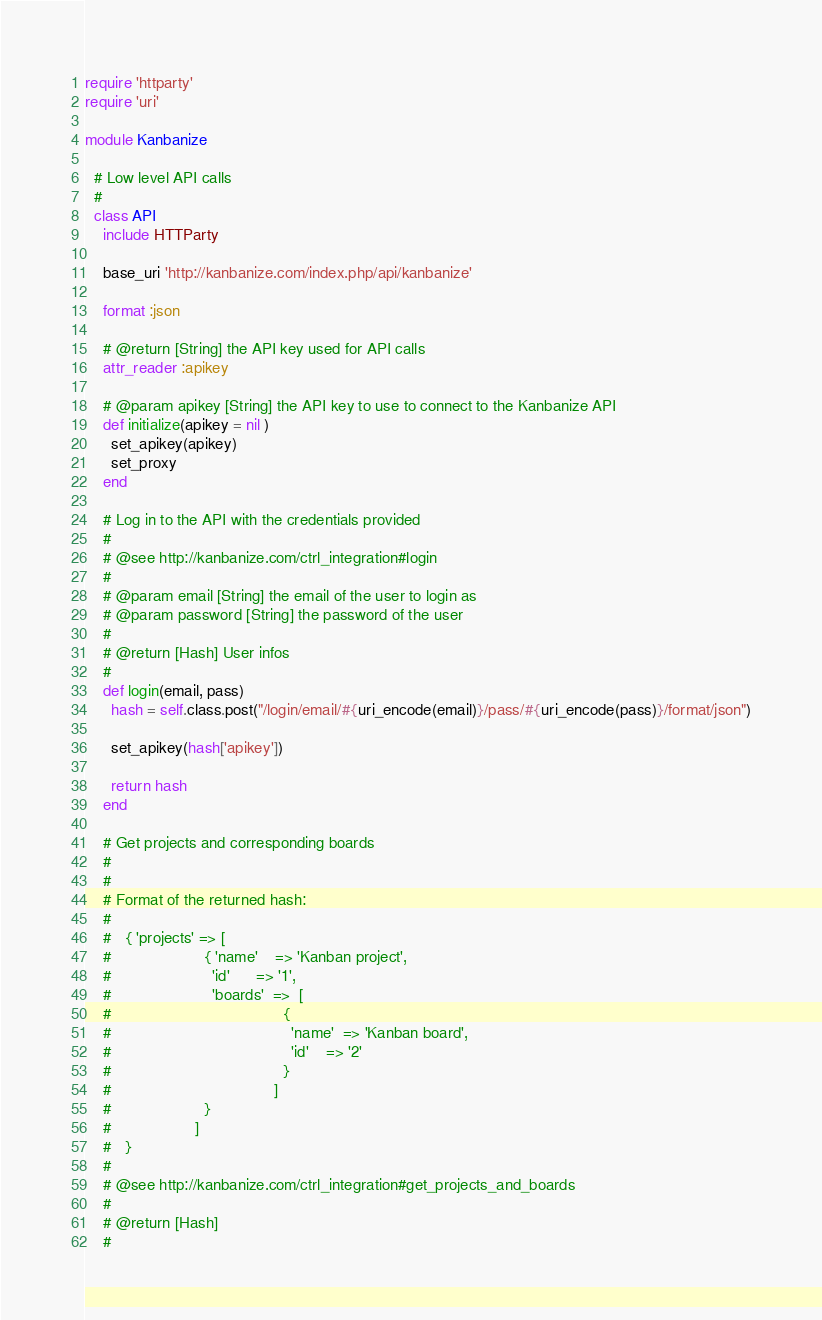<code> <loc_0><loc_0><loc_500><loc_500><_Ruby_>require 'httparty'
require 'uri'

module Kanbanize

  # Low level API calls
  #
  class API
    include HTTParty

    base_uri 'http://kanbanize.com/index.php/api/kanbanize'

    format :json

    # @return [String] the API key used for API calls
    attr_reader :apikey

    # @param apikey [String] the API key to use to connect to the Kanbanize API
    def initialize(apikey = nil )
      set_apikey(apikey)
      set_proxy
    end

    # Log in to the API with the credentials provided
    #
    # @see http://kanbanize.com/ctrl_integration#login
    #
    # @param email [String] the email of the user to login as
    # @param password [String] the password of the user
    #
    # @return [Hash] User infos
    #
    def login(email, pass)
      hash = self.class.post("/login/email/#{uri_encode(email)}/pass/#{uri_encode(pass)}/format/json")

      set_apikey(hash['apikey'])

      return hash
    end

    # Get projects and corresponding boards
    #
    #
    # Format of the returned hash:
    #
    #   { 'projects' => [
    #                     { 'name'    => 'Kanban project',
    #                       'id'      => '1',
    #                       'boards'  =>  [
    #                                       {
    #                                         'name'  => 'Kanban board',
    #                                         'id'    => '2'
    #                                       }
    #                                     ]
    #                     }
    #                   ]
    #   }
    #
    # @see http://kanbanize.com/ctrl_integration#get_projects_and_boards
    #
    # @return [Hash]
    #</code> 